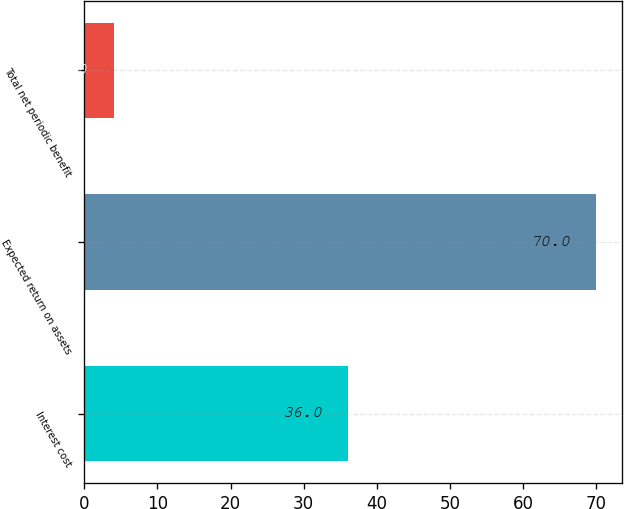Convert chart. <chart><loc_0><loc_0><loc_500><loc_500><bar_chart><fcel>Interest cost<fcel>Expected return on assets<fcel>Total net periodic benefit<nl><fcel>36<fcel>70<fcel>4<nl></chart> 